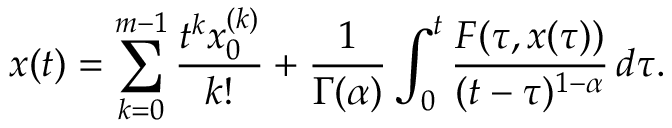Convert formula to latex. <formula><loc_0><loc_0><loc_500><loc_500>x ( t ) = \sum _ { k = 0 } ^ { m - 1 } \frac { t ^ { k } x _ { 0 } ^ { ( k ) } } { k ! } + \frac { 1 } { \Gamma ( \alpha ) } \int _ { 0 } ^ { t } \frac { F ( \tau , x ( \tau ) ) } { ( t - \tau ) ^ { 1 - \alpha } } \, d \tau .</formula> 